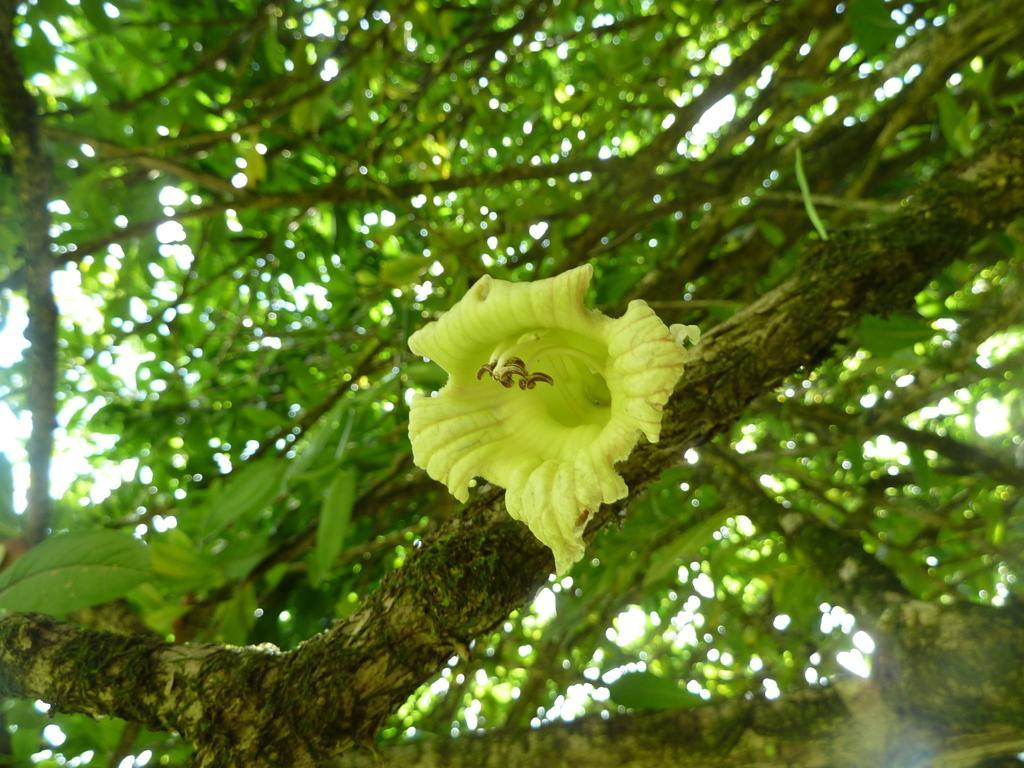Can you describe this image briefly? In the image there is a flower on the branch of a tree and behind that flower there are many leaves to the branches of the trees. 